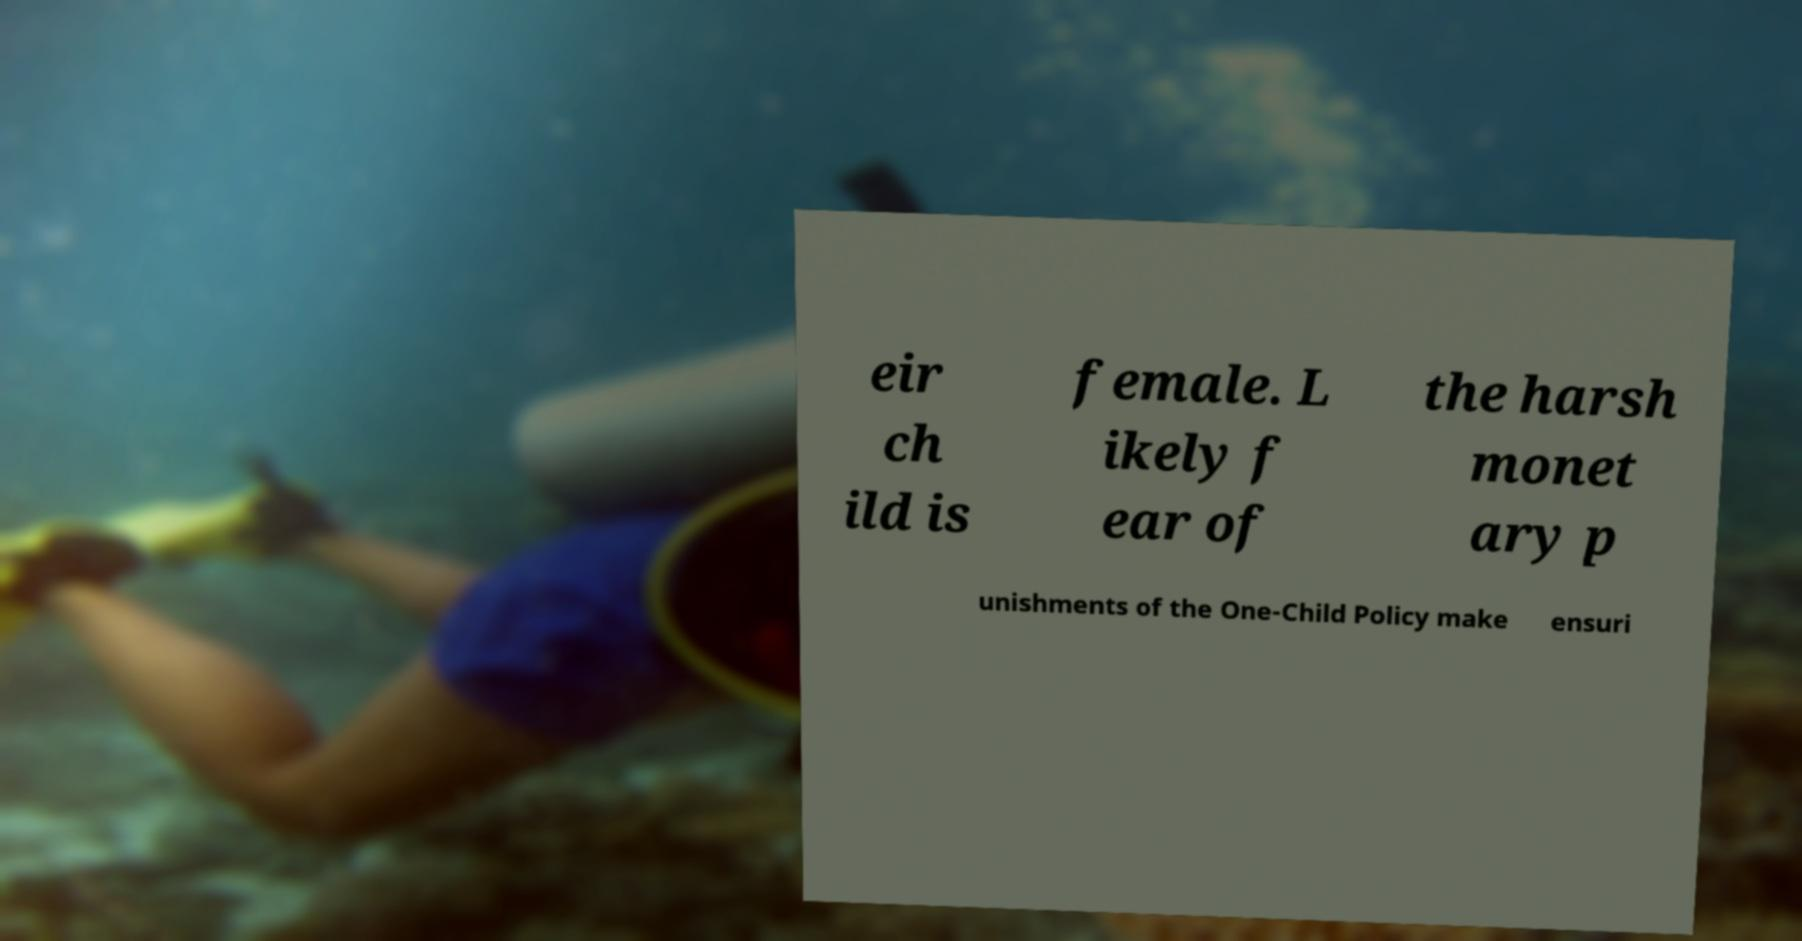Please identify and transcribe the text found in this image. eir ch ild is female. L ikely f ear of the harsh monet ary p unishments of the One-Child Policy make ensuri 